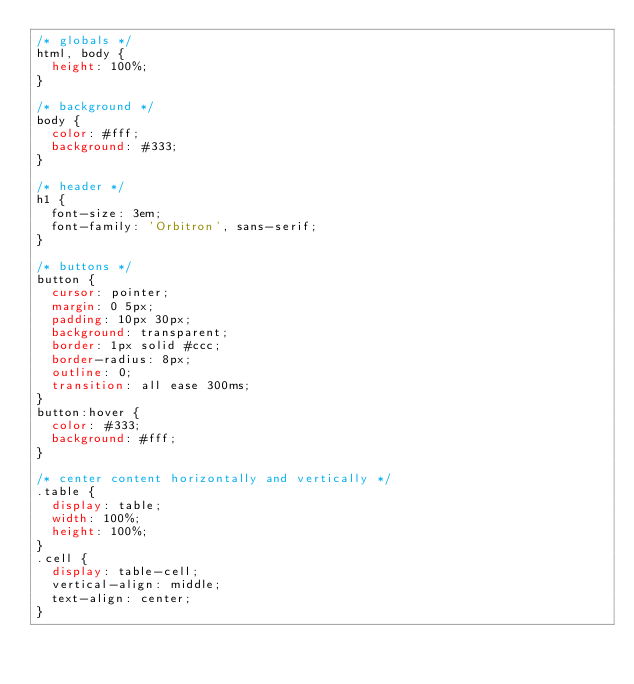Convert code to text. <code><loc_0><loc_0><loc_500><loc_500><_CSS_>/* globals */
html, body {
  height: 100%;
}

/* background */
body {
  color: #fff;
  background: #333;
}

/* header */
h1 {
  font-size: 3em;
  font-family: 'Orbitron', sans-serif;
}

/* buttons */
button {
  cursor: pointer;
  margin: 0 5px;
  padding: 10px 30px;
  background: transparent;
  border: 1px solid #ccc;
  border-radius: 8px;
  outline: 0;
  transition: all ease 300ms;
}
button:hover {
  color: #333;
  background: #fff;
}

/* center content horizontally and vertically */
.table {
  display: table;
  width: 100%;
  height: 100%;
}
.cell {
  display: table-cell;
  vertical-align: middle;
  text-align: center;
}</code> 